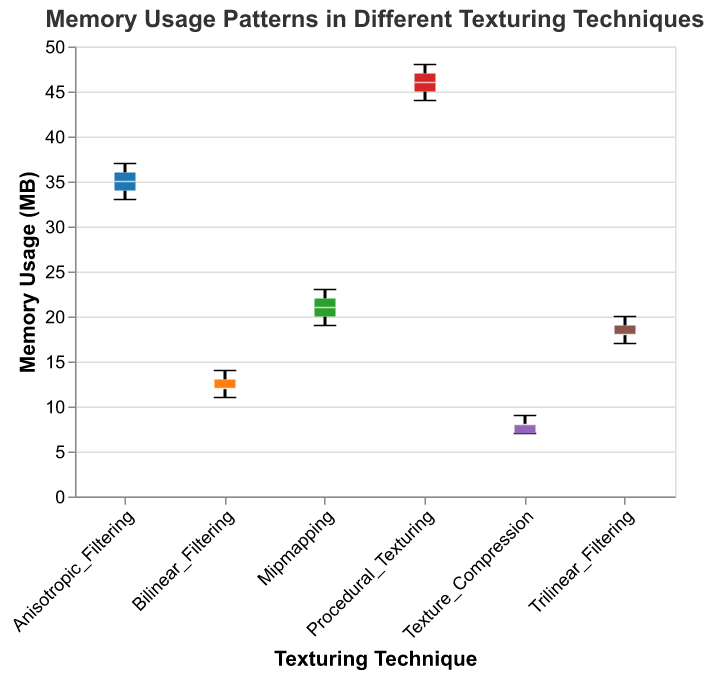What is the title of the figure? The title is located at the top of the figure and provides a summary of what the figure is about. It is "Memory Usage Patterns in Different Texturing Techniques".
Answer: Memory Usage Patterns in Different Texturing Techniques Which texturing technique has the highest median memory usage? To identify the highest median memory usage, look for the horizontal line (median indicator) within each box plot that is at the highest y-axis value. "Procedural_Texturing" has the highest median memory usage as its median line is closest to the top.
Answer: Procedural_Texturing What is the interquartile range (IQR) of the memory usage for Bilinear Filtering? The IQR is the range between the first quartile (Q1, the bottom of the box) and the third quartile (Q3, the top of the box). For Bilinear Filtering, Q1 is at 11 MB and Q3 is at 13 MB. Hence, IQR = Q3 - Q1 = 13 MB - 11 MB.
Answer: 2 MB Which texturing technique exhibits the least variability in memory usage? The least variability can be found by inspecting the height of the box from bottom (Q1) to top (Q3); the smaller the height, the less variability. "Texture_Compression" has the smallest box height, indicating the least variability.
Answer: Texture_Compression What is the median memory usage for Trilinear Filtering? The median value is represented by the horizontal line within the box plot. For Trilinear Filtering, this line is at 18 MB.
Answer: 18 MB How many techniques have their minimum memory usage at or above 19 MB? Look at the bottom whiskers of the box plots and identify which ones do not go below 19 MB. "Mipmapping", "Anisotropic_Filtering", and "Procedural_Texturing" all have their minimum value at or above 19 MB.
Answer: Three Compare the range of memory usage between Anisotropic Filtering and Bilinear Filtering. Which has a larger range? The range is the difference between the maximum and minimum values (top and bottom whiskers). For Anisotropic Filtering, it ranges from 33 MB to 37 MB (range = 4 MB). For Bilinear Filtering, it ranges from 11 MB to 14 MB (range = 3 MB). Hence, Anisotropic Filtering has a larger range.
Answer: Anisotropic Filtering What is the mean memory usage of Texture Compression and Mipmapping combined? Find the mean of each technique and then calculate the overall mean. Texture Compression (7, 7, 8, 8, 9) has a mean of (7+7+8+8+9)/5 = 7.8 MB. Mipmapping (19, 20, 21, 22, 23) has a mean of (19+20+21+22+23)/5 = 21 MB. The combined mean is (7.8 + 21) / 2 = 14.4 MB.
Answer: 14.4 MB What is the difference in median memory usage between Anisotropic Filtering and Texture Compression? Locate the median for both techniques. For Anisotropic Filtering, it is 35 MB. For Texture Compression, it is 8 MB. The difference is 35 MB - 8 MB.
Answer: 27 MB 